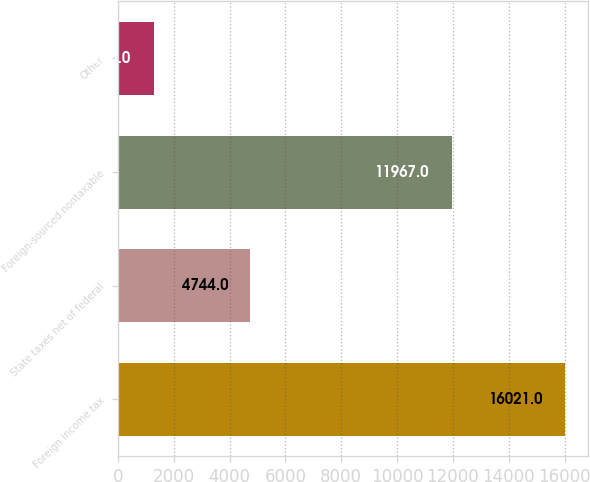Convert chart. <chart><loc_0><loc_0><loc_500><loc_500><bar_chart><fcel>Foreign income tax<fcel>State taxes net of federal<fcel>Foreign-sourced nontaxable<fcel>Other<nl><fcel>16021<fcel>4744<fcel>11967<fcel>1285<nl></chart> 